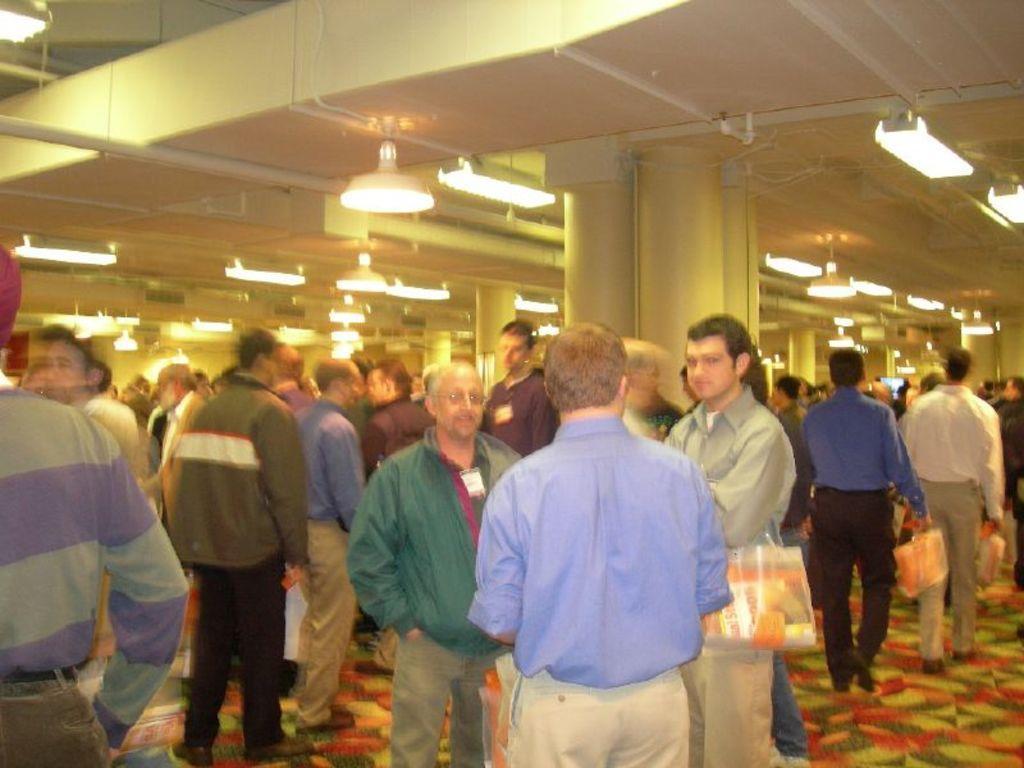Can you describe this image briefly? In this image I can see number of people are standing. I can see few of them are wearing jacket and few of them are wearing shirt. I can also see few people are carrying orange colour things and in the background I can see number of lights. I can also see this image is little bit blurry. 